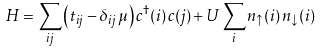<formula> <loc_0><loc_0><loc_500><loc_500>H = \sum _ { i j } \left ( t _ { i j } - \delta _ { i j } \, \mu \right ) c ^ { \dagger } ( i ) \, c ( j ) + U \sum _ { i } n _ { \uparrow } ( i ) \, n _ { \downarrow } ( i )</formula> 